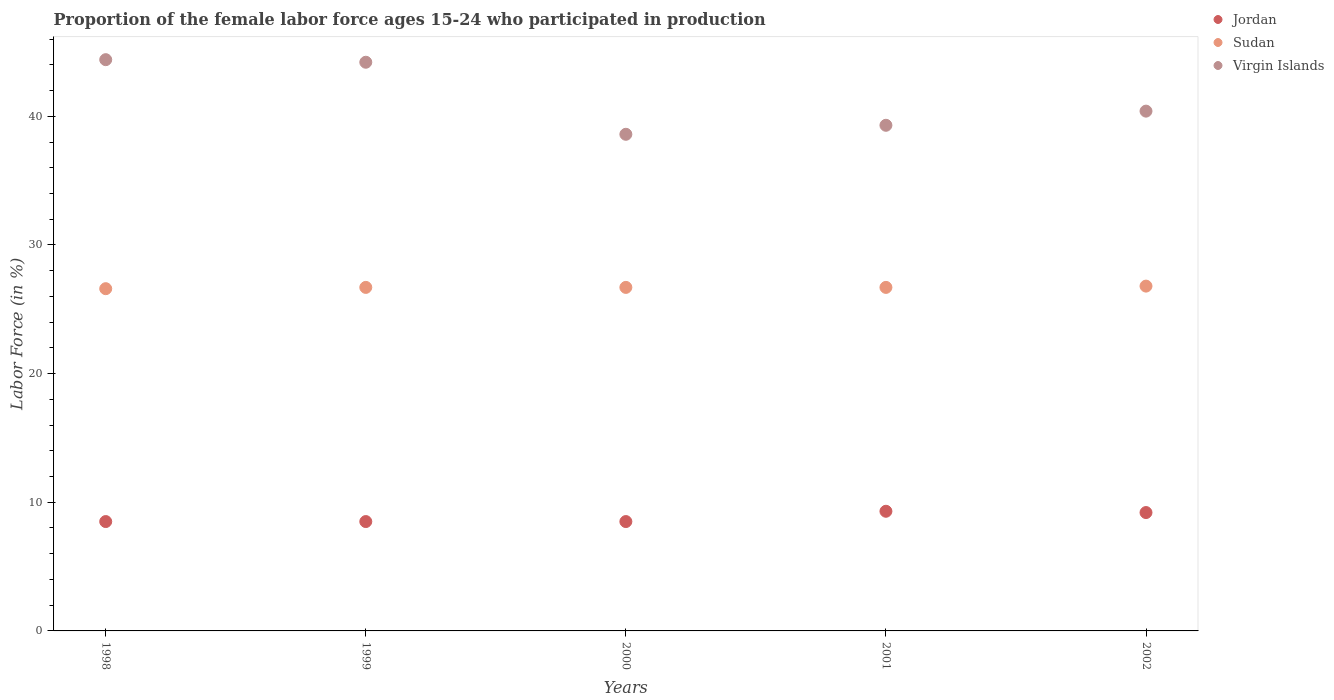How many different coloured dotlines are there?
Provide a short and direct response. 3. What is the proportion of the female labor force who participated in production in Sudan in 2002?
Ensure brevity in your answer.  26.8. Across all years, what is the maximum proportion of the female labor force who participated in production in Sudan?
Provide a succinct answer. 26.8. Across all years, what is the minimum proportion of the female labor force who participated in production in Jordan?
Your answer should be very brief. 8.5. In which year was the proportion of the female labor force who participated in production in Virgin Islands minimum?
Keep it short and to the point. 2000. What is the total proportion of the female labor force who participated in production in Virgin Islands in the graph?
Make the answer very short. 206.9. What is the difference between the proportion of the female labor force who participated in production in Virgin Islands in 1998 and that in 2001?
Offer a very short reply. 5.1. What is the difference between the proportion of the female labor force who participated in production in Virgin Islands in 1998 and the proportion of the female labor force who participated in production in Jordan in 2000?
Offer a very short reply. 35.9. What is the average proportion of the female labor force who participated in production in Sudan per year?
Keep it short and to the point. 26.7. In the year 2000, what is the difference between the proportion of the female labor force who participated in production in Virgin Islands and proportion of the female labor force who participated in production in Jordan?
Offer a very short reply. 30.1. In how many years, is the proportion of the female labor force who participated in production in Virgin Islands greater than 34 %?
Your answer should be compact. 5. What is the ratio of the proportion of the female labor force who participated in production in Virgin Islands in 2001 to that in 2002?
Give a very brief answer. 0.97. Is the proportion of the female labor force who participated in production in Jordan in 1999 less than that in 2001?
Your answer should be very brief. Yes. Is the difference between the proportion of the female labor force who participated in production in Virgin Islands in 1999 and 2001 greater than the difference between the proportion of the female labor force who participated in production in Jordan in 1999 and 2001?
Your response must be concise. Yes. What is the difference between the highest and the second highest proportion of the female labor force who participated in production in Sudan?
Your answer should be very brief. 0.1. What is the difference between the highest and the lowest proportion of the female labor force who participated in production in Virgin Islands?
Your answer should be compact. 5.8. Is the proportion of the female labor force who participated in production in Virgin Islands strictly greater than the proportion of the female labor force who participated in production in Sudan over the years?
Your answer should be very brief. Yes. How many dotlines are there?
Offer a very short reply. 3. What is the difference between two consecutive major ticks on the Y-axis?
Ensure brevity in your answer.  10. Does the graph contain grids?
Keep it short and to the point. No. How are the legend labels stacked?
Give a very brief answer. Vertical. What is the title of the graph?
Ensure brevity in your answer.  Proportion of the female labor force ages 15-24 who participated in production. What is the label or title of the Y-axis?
Keep it short and to the point. Labor Force (in %). What is the Labor Force (in %) in Sudan in 1998?
Provide a short and direct response. 26.6. What is the Labor Force (in %) of Virgin Islands in 1998?
Offer a very short reply. 44.4. What is the Labor Force (in %) of Sudan in 1999?
Offer a very short reply. 26.7. What is the Labor Force (in %) in Virgin Islands in 1999?
Ensure brevity in your answer.  44.2. What is the Labor Force (in %) of Sudan in 2000?
Make the answer very short. 26.7. What is the Labor Force (in %) in Virgin Islands in 2000?
Give a very brief answer. 38.6. What is the Labor Force (in %) of Jordan in 2001?
Ensure brevity in your answer.  9.3. What is the Labor Force (in %) of Sudan in 2001?
Your response must be concise. 26.7. What is the Labor Force (in %) of Virgin Islands in 2001?
Make the answer very short. 39.3. What is the Labor Force (in %) of Jordan in 2002?
Provide a succinct answer. 9.2. What is the Labor Force (in %) in Sudan in 2002?
Your response must be concise. 26.8. What is the Labor Force (in %) in Virgin Islands in 2002?
Provide a succinct answer. 40.4. Across all years, what is the maximum Labor Force (in %) of Jordan?
Provide a short and direct response. 9.3. Across all years, what is the maximum Labor Force (in %) of Sudan?
Give a very brief answer. 26.8. Across all years, what is the maximum Labor Force (in %) in Virgin Islands?
Your answer should be very brief. 44.4. Across all years, what is the minimum Labor Force (in %) of Jordan?
Keep it short and to the point. 8.5. Across all years, what is the minimum Labor Force (in %) of Sudan?
Provide a succinct answer. 26.6. Across all years, what is the minimum Labor Force (in %) of Virgin Islands?
Offer a terse response. 38.6. What is the total Labor Force (in %) in Jordan in the graph?
Give a very brief answer. 44. What is the total Labor Force (in %) of Sudan in the graph?
Your response must be concise. 133.5. What is the total Labor Force (in %) in Virgin Islands in the graph?
Your response must be concise. 206.9. What is the difference between the Labor Force (in %) of Sudan in 1998 and that in 1999?
Give a very brief answer. -0.1. What is the difference between the Labor Force (in %) of Sudan in 1998 and that in 2000?
Your response must be concise. -0.1. What is the difference between the Labor Force (in %) in Jordan in 1998 and that in 2001?
Give a very brief answer. -0.8. What is the difference between the Labor Force (in %) in Virgin Islands in 1998 and that in 2001?
Your answer should be compact. 5.1. What is the difference between the Labor Force (in %) in Jordan in 1998 and that in 2002?
Offer a very short reply. -0.7. What is the difference between the Labor Force (in %) of Sudan in 1999 and that in 2001?
Provide a short and direct response. 0. What is the difference between the Labor Force (in %) of Jordan in 1999 and that in 2002?
Ensure brevity in your answer.  -0.7. What is the difference between the Labor Force (in %) of Sudan in 1999 and that in 2002?
Offer a very short reply. -0.1. What is the difference between the Labor Force (in %) of Virgin Islands in 1999 and that in 2002?
Your answer should be compact. 3.8. What is the difference between the Labor Force (in %) in Jordan in 2000 and that in 2001?
Offer a very short reply. -0.8. What is the difference between the Labor Force (in %) in Sudan in 2000 and that in 2001?
Offer a terse response. 0. What is the difference between the Labor Force (in %) in Jordan in 2000 and that in 2002?
Offer a very short reply. -0.7. What is the difference between the Labor Force (in %) in Virgin Islands in 2000 and that in 2002?
Give a very brief answer. -1.8. What is the difference between the Labor Force (in %) of Jordan in 2001 and that in 2002?
Keep it short and to the point. 0.1. What is the difference between the Labor Force (in %) in Virgin Islands in 2001 and that in 2002?
Provide a short and direct response. -1.1. What is the difference between the Labor Force (in %) in Jordan in 1998 and the Labor Force (in %) in Sudan in 1999?
Your answer should be compact. -18.2. What is the difference between the Labor Force (in %) in Jordan in 1998 and the Labor Force (in %) in Virgin Islands in 1999?
Ensure brevity in your answer.  -35.7. What is the difference between the Labor Force (in %) in Sudan in 1998 and the Labor Force (in %) in Virgin Islands in 1999?
Keep it short and to the point. -17.6. What is the difference between the Labor Force (in %) in Jordan in 1998 and the Labor Force (in %) in Sudan in 2000?
Ensure brevity in your answer.  -18.2. What is the difference between the Labor Force (in %) of Jordan in 1998 and the Labor Force (in %) of Virgin Islands in 2000?
Provide a short and direct response. -30.1. What is the difference between the Labor Force (in %) of Jordan in 1998 and the Labor Force (in %) of Sudan in 2001?
Your answer should be compact. -18.2. What is the difference between the Labor Force (in %) of Jordan in 1998 and the Labor Force (in %) of Virgin Islands in 2001?
Provide a short and direct response. -30.8. What is the difference between the Labor Force (in %) in Sudan in 1998 and the Labor Force (in %) in Virgin Islands in 2001?
Provide a short and direct response. -12.7. What is the difference between the Labor Force (in %) of Jordan in 1998 and the Labor Force (in %) of Sudan in 2002?
Your answer should be very brief. -18.3. What is the difference between the Labor Force (in %) of Jordan in 1998 and the Labor Force (in %) of Virgin Islands in 2002?
Your response must be concise. -31.9. What is the difference between the Labor Force (in %) in Jordan in 1999 and the Labor Force (in %) in Sudan in 2000?
Your answer should be very brief. -18.2. What is the difference between the Labor Force (in %) of Jordan in 1999 and the Labor Force (in %) of Virgin Islands in 2000?
Make the answer very short. -30.1. What is the difference between the Labor Force (in %) in Sudan in 1999 and the Labor Force (in %) in Virgin Islands in 2000?
Give a very brief answer. -11.9. What is the difference between the Labor Force (in %) in Jordan in 1999 and the Labor Force (in %) in Sudan in 2001?
Provide a short and direct response. -18.2. What is the difference between the Labor Force (in %) of Jordan in 1999 and the Labor Force (in %) of Virgin Islands in 2001?
Offer a terse response. -30.8. What is the difference between the Labor Force (in %) of Sudan in 1999 and the Labor Force (in %) of Virgin Islands in 2001?
Your answer should be compact. -12.6. What is the difference between the Labor Force (in %) of Jordan in 1999 and the Labor Force (in %) of Sudan in 2002?
Your answer should be very brief. -18.3. What is the difference between the Labor Force (in %) in Jordan in 1999 and the Labor Force (in %) in Virgin Islands in 2002?
Give a very brief answer. -31.9. What is the difference between the Labor Force (in %) in Sudan in 1999 and the Labor Force (in %) in Virgin Islands in 2002?
Your answer should be very brief. -13.7. What is the difference between the Labor Force (in %) of Jordan in 2000 and the Labor Force (in %) of Sudan in 2001?
Your answer should be compact. -18.2. What is the difference between the Labor Force (in %) in Jordan in 2000 and the Labor Force (in %) in Virgin Islands in 2001?
Keep it short and to the point. -30.8. What is the difference between the Labor Force (in %) in Sudan in 2000 and the Labor Force (in %) in Virgin Islands in 2001?
Offer a terse response. -12.6. What is the difference between the Labor Force (in %) in Jordan in 2000 and the Labor Force (in %) in Sudan in 2002?
Your answer should be very brief. -18.3. What is the difference between the Labor Force (in %) in Jordan in 2000 and the Labor Force (in %) in Virgin Islands in 2002?
Offer a terse response. -31.9. What is the difference between the Labor Force (in %) of Sudan in 2000 and the Labor Force (in %) of Virgin Islands in 2002?
Your response must be concise. -13.7. What is the difference between the Labor Force (in %) in Jordan in 2001 and the Labor Force (in %) in Sudan in 2002?
Give a very brief answer. -17.5. What is the difference between the Labor Force (in %) of Jordan in 2001 and the Labor Force (in %) of Virgin Islands in 2002?
Offer a terse response. -31.1. What is the difference between the Labor Force (in %) of Sudan in 2001 and the Labor Force (in %) of Virgin Islands in 2002?
Provide a short and direct response. -13.7. What is the average Labor Force (in %) in Sudan per year?
Provide a succinct answer. 26.7. What is the average Labor Force (in %) in Virgin Islands per year?
Keep it short and to the point. 41.38. In the year 1998, what is the difference between the Labor Force (in %) in Jordan and Labor Force (in %) in Sudan?
Ensure brevity in your answer.  -18.1. In the year 1998, what is the difference between the Labor Force (in %) of Jordan and Labor Force (in %) of Virgin Islands?
Ensure brevity in your answer.  -35.9. In the year 1998, what is the difference between the Labor Force (in %) in Sudan and Labor Force (in %) in Virgin Islands?
Make the answer very short. -17.8. In the year 1999, what is the difference between the Labor Force (in %) in Jordan and Labor Force (in %) in Sudan?
Provide a short and direct response. -18.2. In the year 1999, what is the difference between the Labor Force (in %) of Jordan and Labor Force (in %) of Virgin Islands?
Make the answer very short. -35.7. In the year 1999, what is the difference between the Labor Force (in %) in Sudan and Labor Force (in %) in Virgin Islands?
Your answer should be compact. -17.5. In the year 2000, what is the difference between the Labor Force (in %) of Jordan and Labor Force (in %) of Sudan?
Ensure brevity in your answer.  -18.2. In the year 2000, what is the difference between the Labor Force (in %) of Jordan and Labor Force (in %) of Virgin Islands?
Your answer should be compact. -30.1. In the year 2001, what is the difference between the Labor Force (in %) of Jordan and Labor Force (in %) of Sudan?
Your response must be concise. -17.4. In the year 2001, what is the difference between the Labor Force (in %) in Jordan and Labor Force (in %) in Virgin Islands?
Your response must be concise. -30. In the year 2001, what is the difference between the Labor Force (in %) in Sudan and Labor Force (in %) in Virgin Islands?
Your response must be concise. -12.6. In the year 2002, what is the difference between the Labor Force (in %) of Jordan and Labor Force (in %) of Sudan?
Keep it short and to the point. -17.6. In the year 2002, what is the difference between the Labor Force (in %) in Jordan and Labor Force (in %) in Virgin Islands?
Give a very brief answer. -31.2. In the year 2002, what is the difference between the Labor Force (in %) in Sudan and Labor Force (in %) in Virgin Islands?
Ensure brevity in your answer.  -13.6. What is the ratio of the Labor Force (in %) of Virgin Islands in 1998 to that in 2000?
Offer a terse response. 1.15. What is the ratio of the Labor Force (in %) of Jordan in 1998 to that in 2001?
Give a very brief answer. 0.91. What is the ratio of the Labor Force (in %) in Sudan in 1998 to that in 2001?
Ensure brevity in your answer.  1. What is the ratio of the Labor Force (in %) of Virgin Islands in 1998 to that in 2001?
Provide a succinct answer. 1.13. What is the ratio of the Labor Force (in %) in Jordan in 1998 to that in 2002?
Ensure brevity in your answer.  0.92. What is the ratio of the Labor Force (in %) of Sudan in 1998 to that in 2002?
Offer a terse response. 0.99. What is the ratio of the Labor Force (in %) in Virgin Islands in 1998 to that in 2002?
Provide a succinct answer. 1.1. What is the ratio of the Labor Force (in %) in Jordan in 1999 to that in 2000?
Your answer should be very brief. 1. What is the ratio of the Labor Force (in %) in Sudan in 1999 to that in 2000?
Your answer should be very brief. 1. What is the ratio of the Labor Force (in %) of Virgin Islands in 1999 to that in 2000?
Ensure brevity in your answer.  1.15. What is the ratio of the Labor Force (in %) in Jordan in 1999 to that in 2001?
Your answer should be very brief. 0.91. What is the ratio of the Labor Force (in %) in Virgin Islands in 1999 to that in 2001?
Your response must be concise. 1.12. What is the ratio of the Labor Force (in %) of Jordan in 1999 to that in 2002?
Keep it short and to the point. 0.92. What is the ratio of the Labor Force (in %) of Sudan in 1999 to that in 2002?
Your answer should be very brief. 1. What is the ratio of the Labor Force (in %) of Virgin Islands in 1999 to that in 2002?
Your answer should be compact. 1.09. What is the ratio of the Labor Force (in %) of Jordan in 2000 to that in 2001?
Keep it short and to the point. 0.91. What is the ratio of the Labor Force (in %) in Virgin Islands in 2000 to that in 2001?
Make the answer very short. 0.98. What is the ratio of the Labor Force (in %) of Jordan in 2000 to that in 2002?
Provide a succinct answer. 0.92. What is the ratio of the Labor Force (in %) in Virgin Islands in 2000 to that in 2002?
Give a very brief answer. 0.96. What is the ratio of the Labor Force (in %) of Jordan in 2001 to that in 2002?
Ensure brevity in your answer.  1.01. What is the ratio of the Labor Force (in %) in Sudan in 2001 to that in 2002?
Your answer should be compact. 1. What is the ratio of the Labor Force (in %) of Virgin Islands in 2001 to that in 2002?
Provide a succinct answer. 0.97. What is the difference between the highest and the lowest Labor Force (in %) of Jordan?
Provide a short and direct response. 0.8. What is the difference between the highest and the lowest Labor Force (in %) of Virgin Islands?
Make the answer very short. 5.8. 